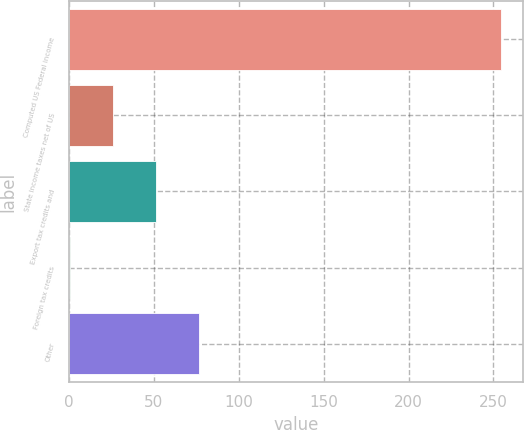Convert chart to OTSL. <chart><loc_0><loc_0><loc_500><loc_500><bar_chart><fcel>Computed US Federal income<fcel>State income taxes net of US<fcel>Export tax credits and<fcel>Foreign tax credits<fcel>Other<nl><fcel>254.7<fcel>25.92<fcel>51.34<fcel>0.5<fcel>76.76<nl></chart> 